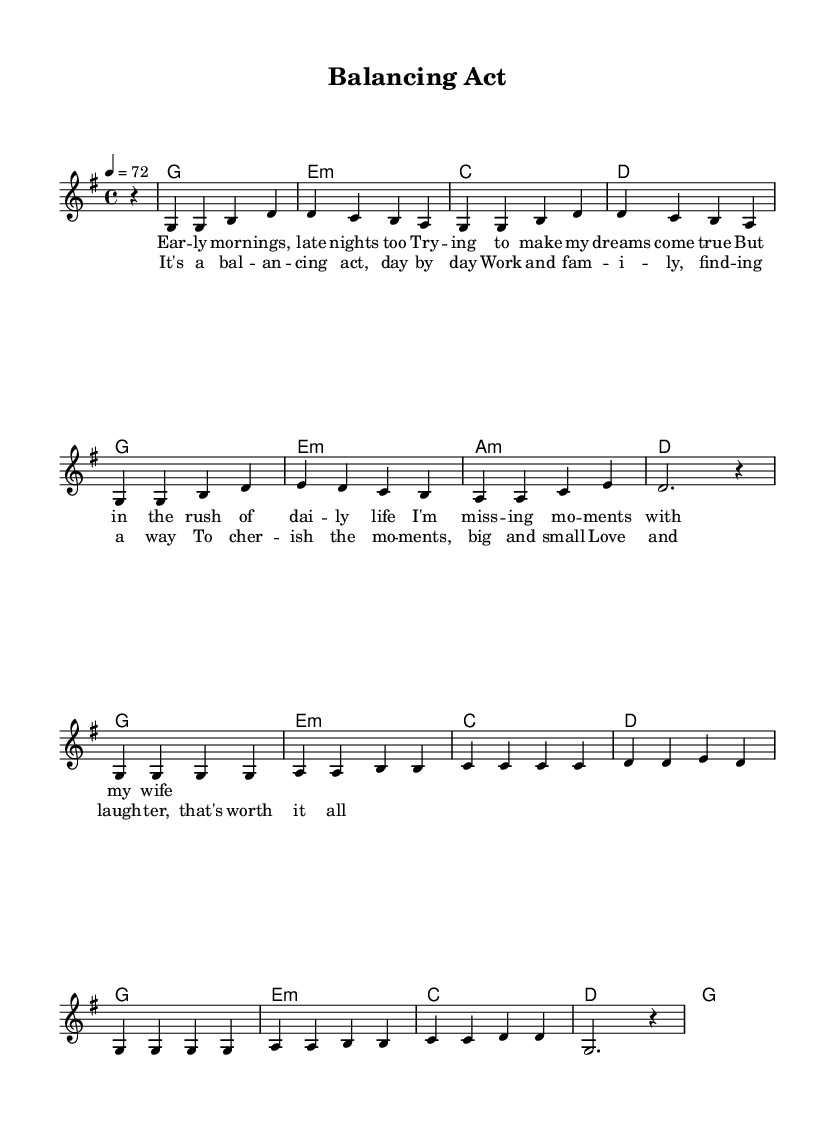What is the key signature of this music? The key signature is G major, which has one sharp (F#). This can be identified at the beginning of the sheet music in the key signature section.
Answer: G major What is the time signature of this music? The time signature is 4/4, which indicates four beats per measure and a quarter note gets one beat. It is shown at the beginning of the score, adjacent to the key signature.
Answer: 4/4 What is the tempo marking for this piece? The tempo marking indicates a speed of 72 beats per minute. This is found in the tempo section of the score, where it is explicitly stated as "4 = 72".
Answer: 72 How many measures are included in the melody? There are eight measures in the melody. Counting the vertical lines (bar lines) indicates the number of measures in the score, which segments the music into these defined intervals.
Answer: 8 Which chord starts the first verse? The first chord of the verse is G major. This can be determined by referencing the harmony line above the melody, where the first chord is labeled at the start of the verse.
Answer: G What are the emotions conveyed in the title of this song? The title "Balancing Act" suggests a theme of struggle or effort to maintain equilibrium between work and family life. This is inferred from the title's wording and the context of the lyrics that follow, which focus on work-life balance.
Answer: Struggle What is the primary theme of the lyrics in this piece? The primary theme of the lyrics revolves around work-life balance and the importance of making family time. This is established through the lyrics discussing daily life and the need to cherish moments with family, reflecting the overarching message of the song.
Answer: Family time 